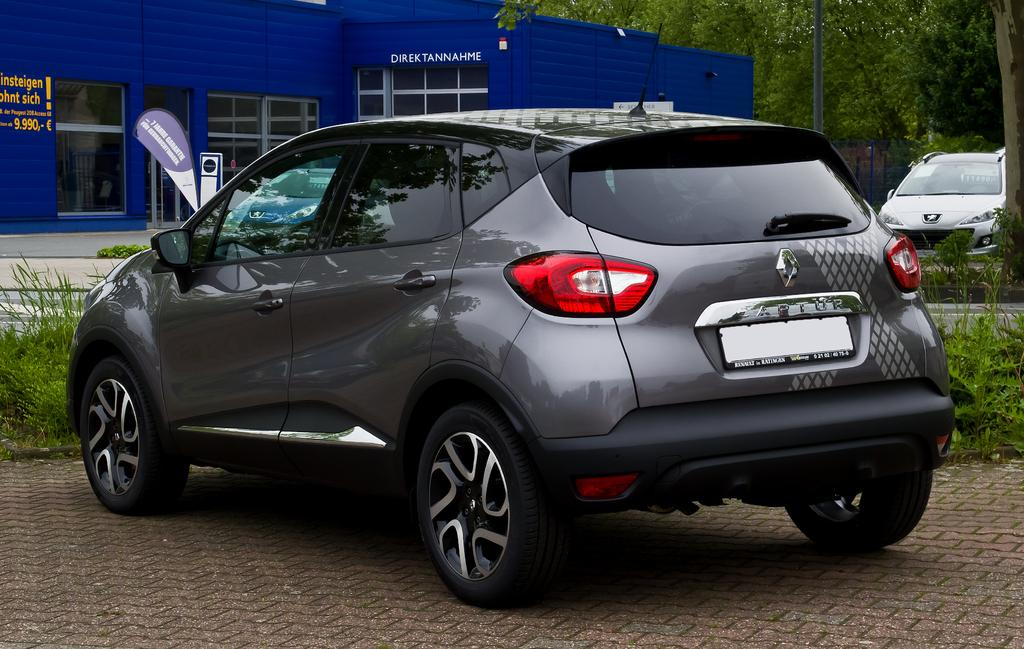What is the main subject in the foreground of the image? There is a car on the pavement in the foreground of the image. What type of vegetation is behind the car? There is grass behind the car. What can be seen in the background of the image? There is a shelter, a road, and trees visible in the background. Are there any other cars in the image? Yes, there is another car on the right side in the background. What reward does the judge give to the person who answers the question correctly in the image? There is no judge or question-and-answer session present in the image. 